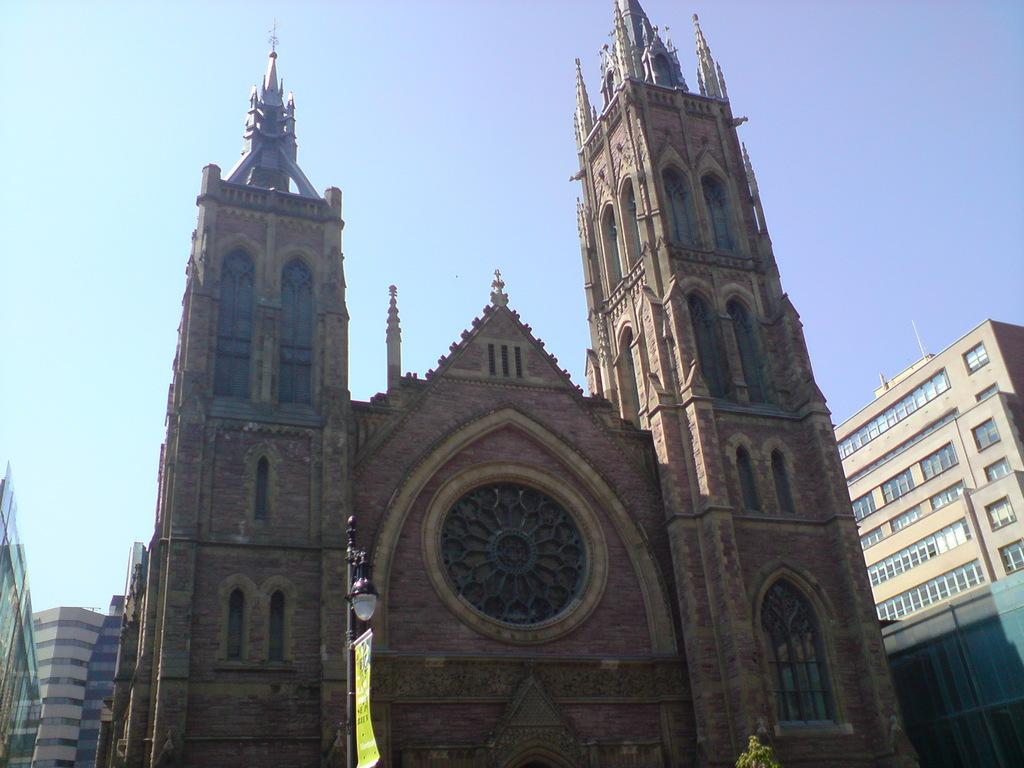What is the main structure in the middle of the image? There is a big church in the middle of the image. What other structures can be seen in the image? There are buildings in the image. What type of vegetation is present in the image? There is a tree in the image. What is the purpose of the light with a pole in front of the church? The light with a pole is likely for illumination purposes. What is visible at the top of the image? The sky is visible at the top of the image. What type of grain is being harvested in the image? There is no grain or harvesting activity present in the image. How many yams are visible in the image? There are no yams present in the image. 